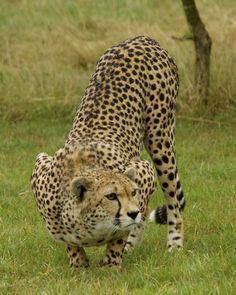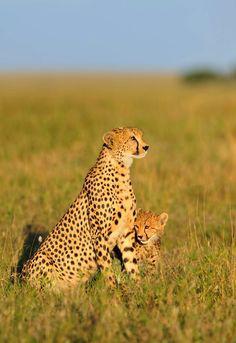The first image is the image on the left, the second image is the image on the right. Assess this claim about the two images: "At least one baby cheetah is looking straight into the camera.". Correct or not? Answer yes or no. No. The first image is the image on the left, the second image is the image on the right. Given the left and right images, does the statement "One image features exactly one young cheetah next to an adult cheetah sitting upright with its head and body facing right." hold true? Answer yes or no. Yes. 